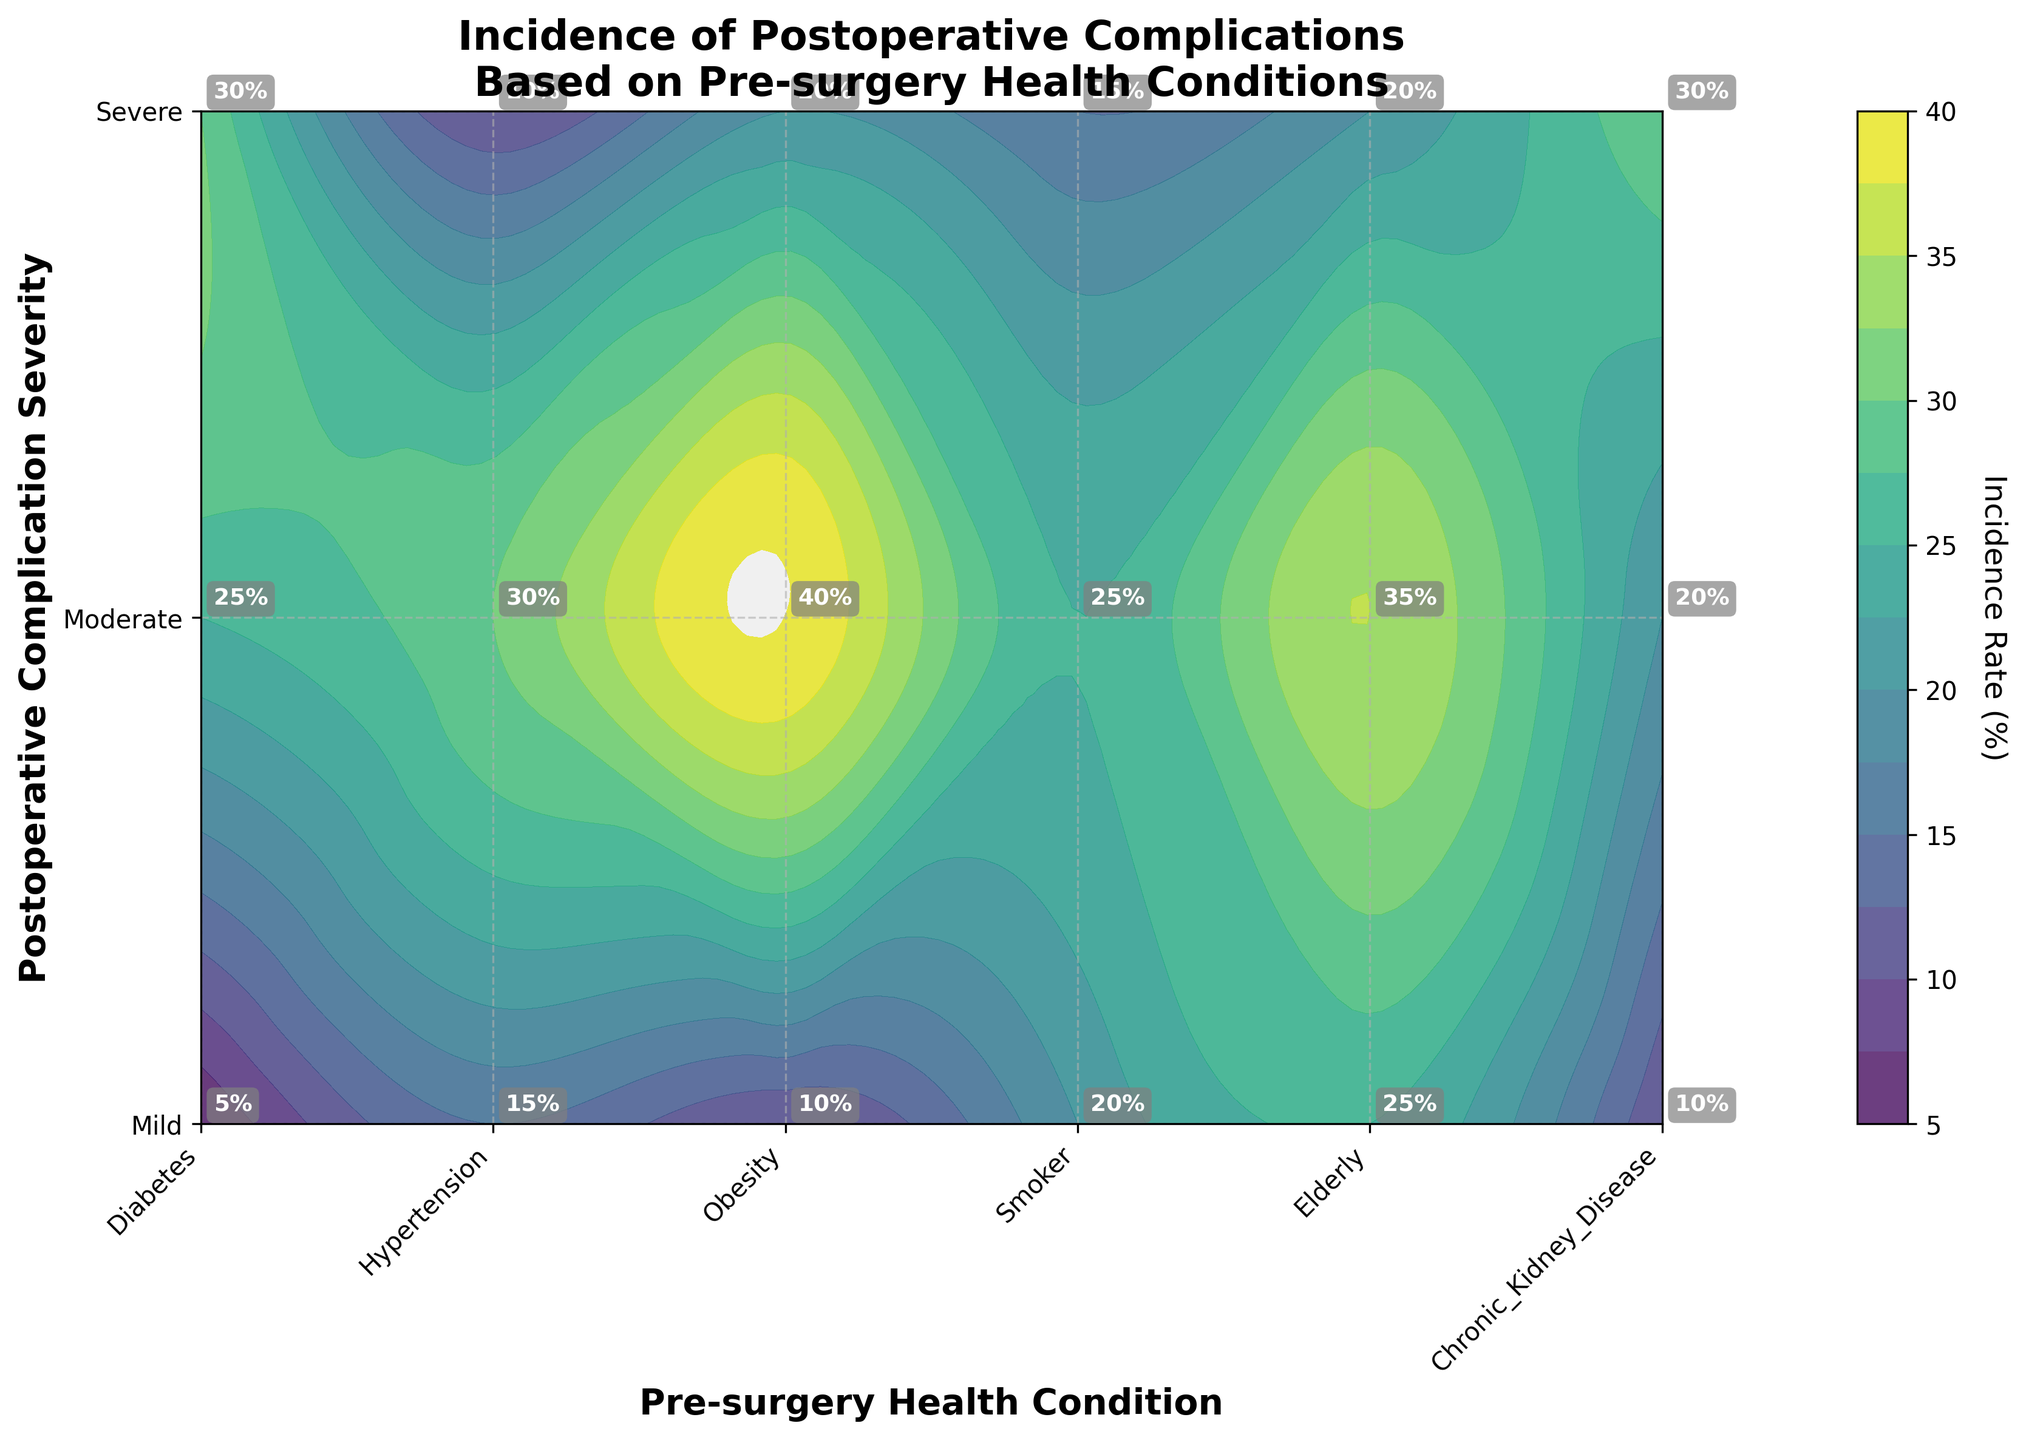how many unique pre-surgery health conditions are represented on the plot? The x-axis represents different pre-surgery health conditions. Counting the unique labels, we have Diabetes, Hypertension, Obesity, Smoker, Elderly, and Chronic Kidney Disease.
Answer: 6 Which pre-surgery health condition has the highest incidence rate of severe postoperative complications? Look at the severe complication level on the y-axis and identify the health condition with the highest contour value. The highest incidence rate for severe complications corresponds to Smokers at a rate of 30%.
Answer: Smoker What is the average incidence rate of mild postoperative complications for all health conditions? Identify the incidence rates for mild complications across all health conditions. These are: Diabetes (15), Hypertension (20), Obesity (25), Smoker (10), Elderly (10), and Chronic Kidney Disease (5). Sum these rates (15 + 20 + 25 + 10 + 10 + 5 = 85) and then divide by the number of conditions (6).
Answer: 14.17% How does the incidence rate of moderate complications for obesity compare to hypertension? Look at the contour values for moderate complications for both health conditions. Obesity has an incidence rate of 35%, while Hypertension has 25%. Compare these values.
Answer: 35% for Obesity and 25% for Hypertension Which health condition has the lowest incidence rate for mild complications? Identify the lowest contour value within the mild complication severity level. Chronic Kidney Disease has the lowest rate at 5%.
Answer: Chronic Kidney Disease What pattern do you observe in the incidence rate of complications for elderly patients as the severity increases? Examine the contour values for elderly patients across mild, moderate, and severe complication severities. The rate starts at 10% for mild, rises significantly to 40% for moderate, and then drops to 20% for severe.
Answer: Increases from mild to moderate, then decreases at severe Is there a pre-surgery health condition where the incidence rate for mild complications is equal to the rate for severe complications? Compare the incidence rates for mild and severe complications across all health conditions. For elderly patients, both mild and severe complication incidence rates are 10%.
Answer: Elderly Which complication severity has the highest overall incidence rate and for which health condition? Look over the contour plot for the peak incidence rate regardless of severity and health condition. The highest incidence rate is 40% for moderate complications for elderly patients.
Answer: Moderate for Elderly What is the total incidence rate for moderate complications when summing for all health conditions? Add the incidence rates of moderate complications for each health condition: Diabetes (30), Hypertension (25), Obesity (35), Smoker (20), Elderly (40), and Chronic Kidney Disease (25). (30 + 25 + 35 + 20 + 40 + 25 = 175).
Answer: 175 Across all health conditions, which severity shows the most variation in incidence rates? Compare the range of incidence rates across all severities. Mild ranges from 5% to 25% (20% range), moderate ranges from 20% to 40% (20% range), and severe ranges from 10% to 30% (20% range). Since all ranges are equal, note that moderate has the highest absolute peaks.
Answer: Moderate 